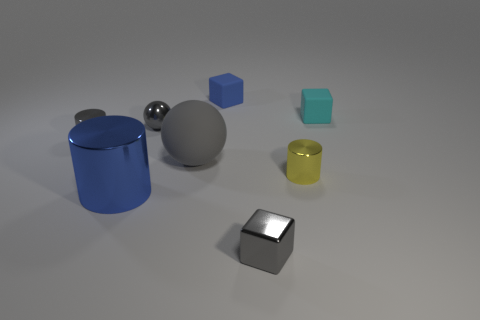Does the tiny metal ball have the same color as the large matte object?
Keep it short and to the point. Yes. How many tiny cyan cubes are to the left of the big blue metal cylinder that is on the left side of the large gray matte thing?
Offer a very short reply. 0. What is the thing that is on the right side of the big metal object and in front of the yellow metal cylinder made of?
Ensure brevity in your answer.  Metal. There is a blue rubber object that is the same size as the gray block; what is its shape?
Your answer should be compact. Cube. There is a rubber block that is on the left side of the small cylinder that is on the right side of the large cylinder on the left side of the large gray ball; what is its color?
Provide a short and direct response. Blue. How many objects are large objects behind the yellow metallic cylinder or small metal cylinders?
Provide a succinct answer. 3. There is a blue block that is the same size as the cyan block; what is its material?
Offer a terse response. Rubber. What is the large object behind the blue thing that is in front of the tiny gray thing to the left of the blue shiny thing made of?
Provide a succinct answer. Rubber. The big metal cylinder is what color?
Your answer should be very brief. Blue. How many tiny things are either balls or gray shiny cylinders?
Your response must be concise. 2. 